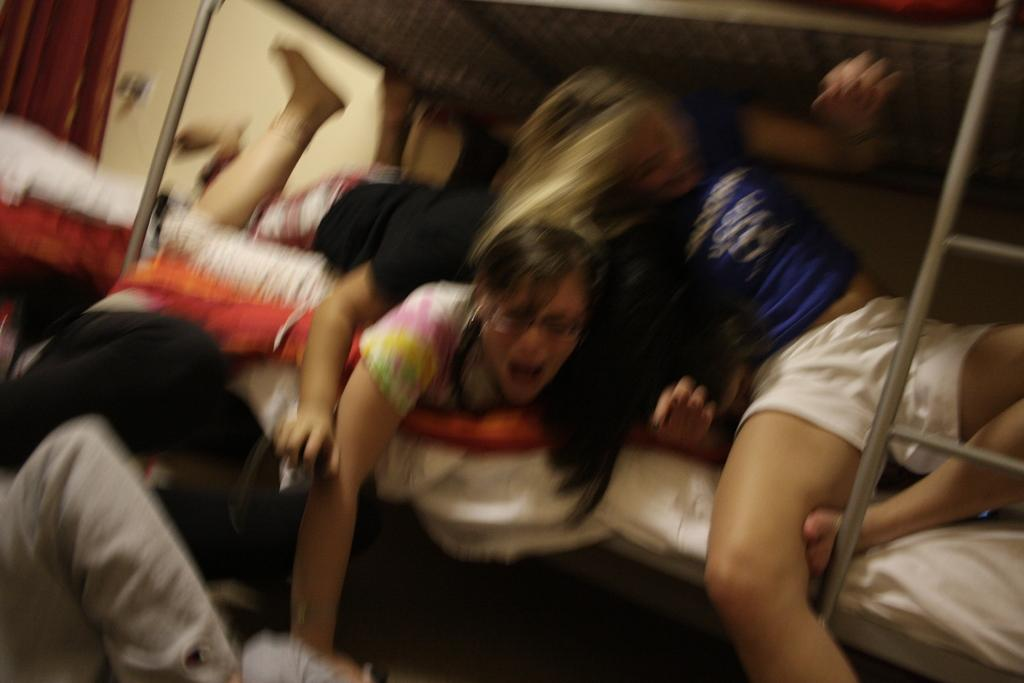What are the persons in the image doing? The persons in the image are on the bed. What can be seen besides the persons on the bed? There are poles and objects on the wall in the image. What type of window treatment is present in the image? There is a curtain in the image. Where is the person located in relation to the bed? There is a person at the bottom of the image. What type of mind-reading apparatus can be seen in the image? There is no mind-reading apparatus present in the image. What type of parent is visible in the image? There is no parent visible in the image. 